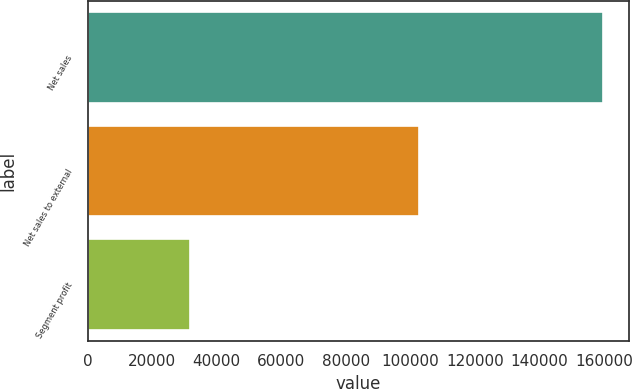Convert chart to OTSL. <chart><loc_0><loc_0><loc_500><loc_500><bar_chart><fcel>Net sales<fcel>Net sales to external<fcel>Segment profit<nl><fcel>159784<fcel>102867<fcel>31705<nl></chart> 